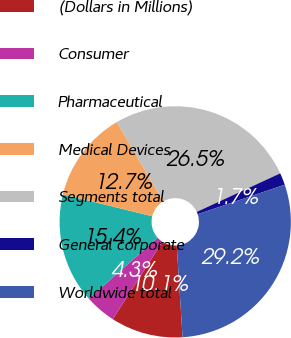Convert chart. <chart><loc_0><loc_0><loc_500><loc_500><pie_chart><fcel>(Dollars in Millions)<fcel>Consumer<fcel>Pharmaceutical<fcel>Medical Devices<fcel>Segments total<fcel>General corporate<fcel>Worldwide total<nl><fcel>10.09%<fcel>4.34%<fcel>15.4%<fcel>12.75%<fcel>26.55%<fcel>1.68%<fcel>29.2%<nl></chart> 